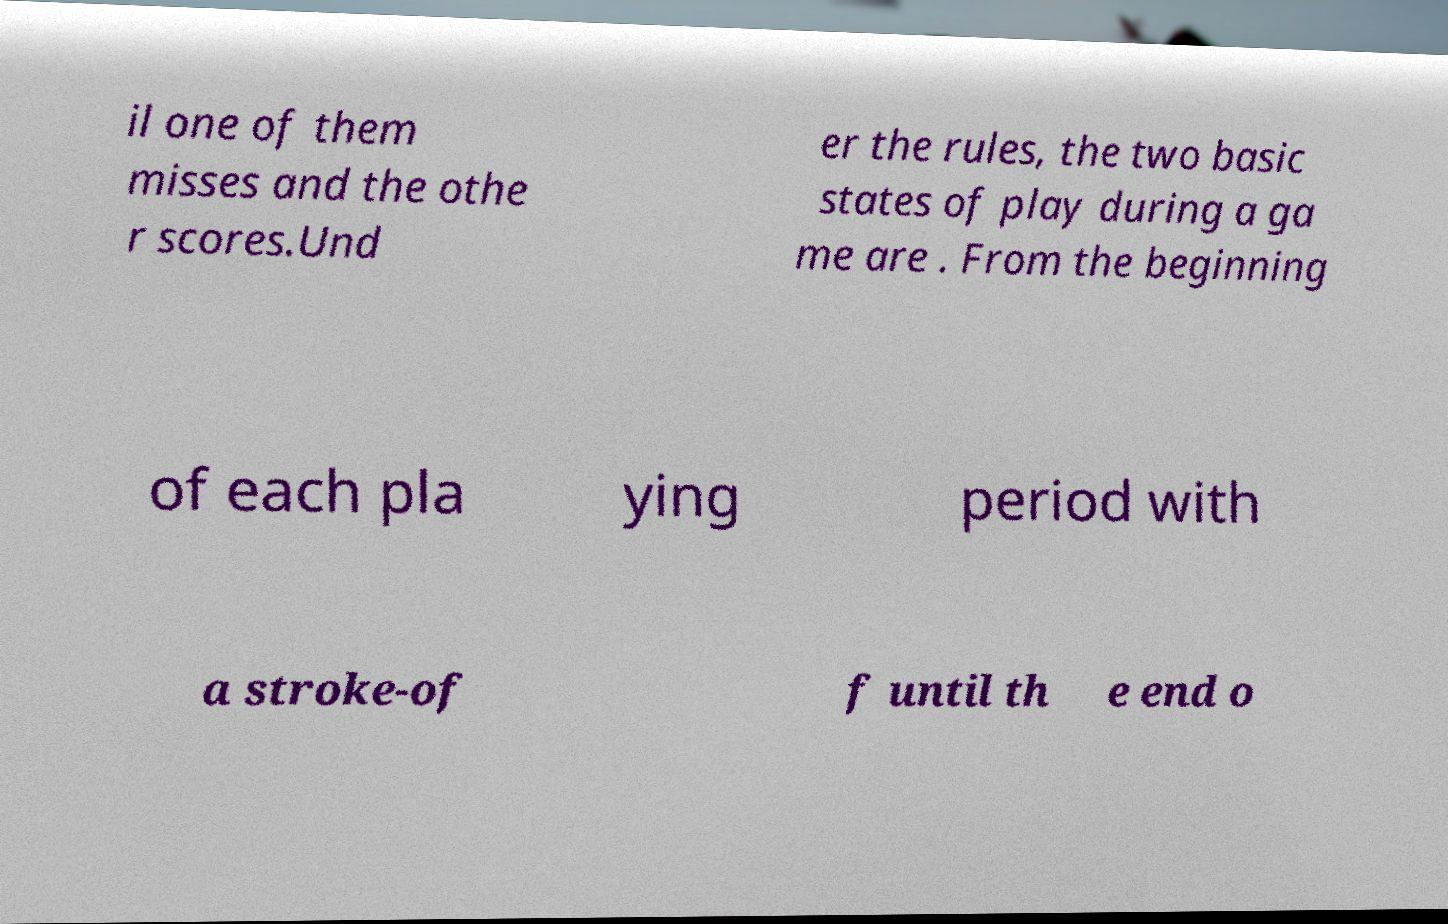Please read and relay the text visible in this image. What does it say? il one of them misses and the othe r scores.Und er the rules, the two basic states of play during a ga me are . From the beginning of each pla ying period with a stroke-of f until th e end o 